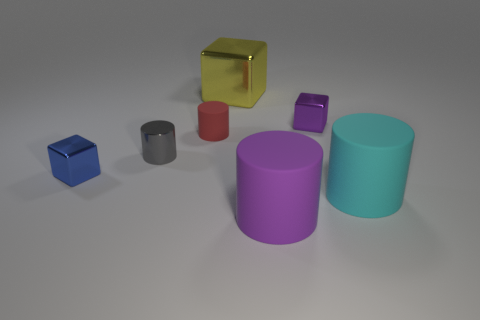There is a tiny thing that is right of the red cylinder behind the blue shiny block; what color is it?
Provide a succinct answer. Purple. There is a purple object in front of the small cube to the left of the small matte cylinder; how big is it?
Your answer should be compact. Large. How many other things are the same size as the red rubber thing?
Your answer should be compact. 3. There is a cube that is to the right of the large cylinder to the left of the big matte cylinder that is to the right of the large purple thing; what is its color?
Your answer should be very brief. Purple. What number of other things are the same shape as the tiny blue object?
Make the answer very short. 2. There is a small object that is right of the big shiny cube; what is its shape?
Make the answer very short. Cube. Are there any tiny red cylinders behind the cube that is left of the large yellow cube?
Give a very brief answer. Yes. There is a object that is behind the cyan thing and in front of the gray metal object; what is its color?
Give a very brief answer. Blue. Is there a small block in front of the tiny gray metal cylinder that is to the right of the small shiny cube on the left side of the large purple cylinder?
Keep it short and to the point. Yes. What size is the purple rubber thing that is the same shape as the cyan object?
Keep it short and to the point. Large. 